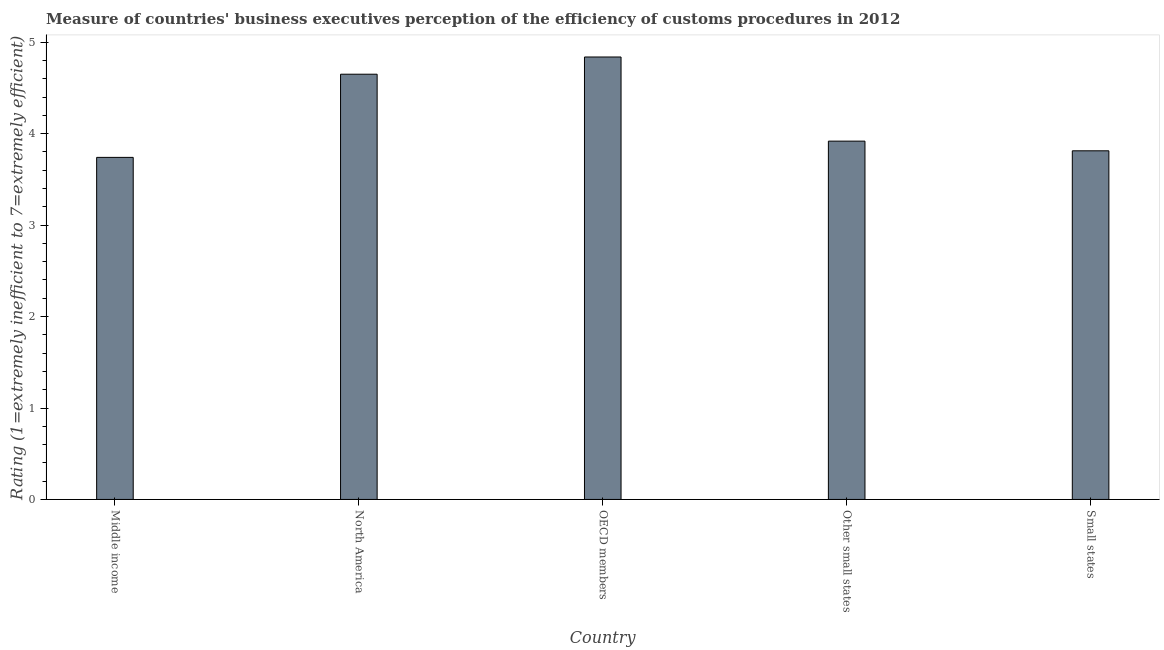What is the title of the graph?
Offer a very short reply. Measure of countries' business executives perception of the efficiency of customs procedures in 2012. What is the label or title of the X-axis?
Your answer should be compact. Country. What is the label or title of the Y-axis?
Your response must be concise. Rating (1=extremely inefficient to 7=extremely efficient). What is the rating measuring burden of customs procedure in North America?
Make the answer very short. 4.65. Across all countries, what is the maximum rating measuring burden of customs procedure?
Offer a terse response. 4.84. Across all countries, what is the minimum rating measuring burden of customs procedure?
Offer a terse response. 3.74. In which country was the rating measuring burden of customs procedure minimum?
Offer a terse response. Middle income. What is the sum of the rating measuring burden of customs procedure?
Provide a short and direct response. 20.96. What is the difference between the rating measuring burden of customs procedure in North America and Small states?
Offer a very short reply. 0.84. What is the average rating measuring burden of customs procedure per country?
Your response must be concise. 4.19. What is the median rating measuring burden of customs procedure?
Provide a short and direct response. 3.92. In how many countries, is the rating measuring burden of customs procedure greater than 1.6 ?
Give a very brief answer. 5. What is the ratio of the rating measuring burden of customs procedure in OECD members to that in Small states?
Your answer should be compact. 1.27. Is the difference between the rating measuring burden of customs procedure in Middle income and North America greater than the difference between any two countries?
Make the answer very short. No. What is the difference between the highest and the second highest rating measuring burden of customs procedure?
Offer a terse response. 0.19. In how many countries, is the rating measuring burden of customs procedure greater than the average rating measuring burden of customs procedure taken over all countries?
Make the answer very short. 2. How many bars are there?
Make the answer very short. 5. Are all the bars in the graph horizontal?
Provide a succinct answer. No. How many countries are there in the graph?
Offer a very short reply. 5. What is the Rating (1=extremely inefficient to 7=extremely efficient) in Middle income?
Ensure brevity in your answer.  3.74. What is the Rating (1=extremely inefficient to 7=extremely efficient) of North America?
Ensure brevity in your answer.  4.65. What is the Rating (1=extremely inefficient to 7=extremely efficient) in OECD members?
Provide a short and direct response. 4.84. What is the Rating (1=extremely inefficient to 7=extremely efficient) of Other small states?
Provide a succinct answer. 3.92. What is the Rating (1=extremely inefficient to 7=extremely efficient) of Small states?
Ensure brevity in your answer.  3.81. What is the difference between the Rating (1=extremely inefficient to 7=extremely efficient) in Middle income and North America?
Give a very brief answer. -0.91. What is the difference between the Rating (1=extremely inefficient to 7=extremely efficient) in Middle income and OECD members?
Ensure brevity in your answer.  -1.1. What is the difference between the Rating (1=extremely inefficient to 7=extremely efficient) in Middle income and Other small states?
Provide a short and direct response. -0.18. What is the difference between the Rating (1=extremely inefficient to 7=extremely efficient) in Middle income and Small states?
Provide a short and direct response. -0.07. What is the difference between the Rating (1=extremely inefficient to 7=extremely efficient) in North America and OECD members?
Make the answer very short. -0.19. What is the difference between the Rating (1=extremely inefficient to 7=extremely efficient) in North America and Other small states?
Ensure brevity in your answer.  0.73. What is the difference between the Rating (1=extremely inefficient to 7=extremely efficient) in North America and Small states?
Make the answer very short. 0.84. What is the difference between the Rating (1=extremely inefficient to 7=extremely efficient) in OECD members and Other small states?
Make the answer very short. 0.92. What is the difference between the Rating (1=extremely inefficient to 7=extremely efficient) in OECD members and Small states?
Make the answer very short. 1.03. What is the difference between the Rating (1=extremely inefficient to 7=extremely efficient) in Other small states and Small states?
Offer a terse response. 0.11. What is the ratio of the Rating (1=extremely inefficient to 7=extremely efficient) in Middle income to that in North America?
Provide a short and direct response. 0.8. What is the ratio of the Rating (1=extremely inefficient to 7=extremely efficient) in Middle income to that in OECD members?
Provide a succinct answer. 0.77. What is the ratio of the Rating (1=extremely inefficient to 7=extremely efficient) in Middle income to that in Other small states?
Your answer should be compact. 0.95. What is the ratio of the Rating (1=extremely inefficient to 7=extremely efficient) in Middle income to that in Small states?
Your answer should be very brief. 0.98. What is the ratio of the Rating (1=extremely inefficient to 7=extremely efficient) in North America to that in Other small states?
Provide a short and direct response. 1.19. What is the ratio of the Rating (1=extremely inefficient to 7=extremely efficient) in North America to that in Small states?
Your answer should be very brief. 1.22. What is the ratio of the Rating (1=extremely inefficient to 7=extremely efficient) in OECD members to that in Other small states?
Your response must be concise. 1.24. What is the ratio of the Rating (1=extremely inefficient to 7=extremely efficient) in OECD members to that in Small states?
Your answer should be very brief. 1.27. What is the ratio of the Rating (1=extremely inefficient to 7=extremely efficient) in Other small states to that in Small states?
Make the answer very short. 1.03. 